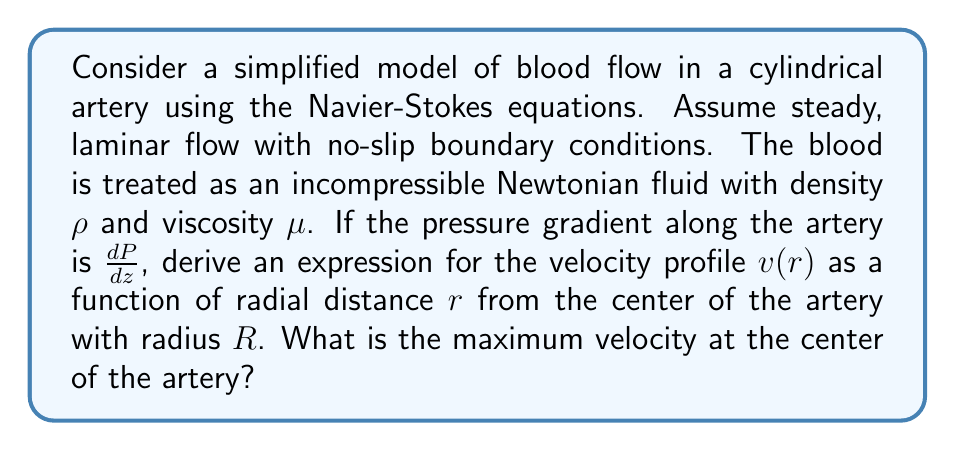Help me with this question. To solve this problem, we'll use the Navier-Stokes equations for incompressible, steady-state flow in cylindrical coordinates. Given the assumptions, we can simplify the equations as follows:

1) The flow is only in the z-direction, so $v_r = v_\theta = 0$ and $v_z = v(r)$.

2) The flow is steady-state, so $\frac{\partial v}{\partial t} = 0$.

3) The pressure gradient is constant along the z-axis: $\frac{dP}{dz} = constant$.

The simplified Navier-Stokes equation in the z-direction becomes:

$$\mu \left(\frac{1}{r}\frac{d}{dr}\left(r\frac{dv}{dr}\right)\right) = \frac{dP}{dz}$$

To solve this equation:

1) Integrate both sides with respect to $r$:

   $$\mu r\frac{dv}{dr} = \frac{1}{2}\frac{dP}{dz}r^2 + C_1$$

2) Divide by $r$ and integrate again:

   $$\mu v = \frac{1}{4}\frac{dP}{dz}r^2 + C_1\ln(r) + C_2$$

3) Apply boundary conditions:
   - At $r = R$, $v = 0$ (no-slip condition)
   - At $r = 0$, $\frac{dv}{dr} = 0$ (symmetry condition)

4) From the symmetry condition, we find that $C_1 = 0$.

5) From the no-slip condition:

   $$0 = \frac{1}{4}\frac{dP}{dz}R^2 + C_2$$
   $$C_2 = -\frac{1}{4}\frac{dP}{dz}R^2$$

6) Substituting back, we get the velocity profile:

   $$v(r) = \frac{1}{4\mu}\frac{dP}{dz}(r^2 - R^2)$$

7) The maximum velocity occurs at the center ($r = 0$):

   $$v_{max} = -\frac{R^2}{4\mu}\frac{dP}{dz}$$

Note that $\frac{dP}{dz}$ is negative as pressure decreases along the flow direction, making $v_{max}$ positive.
Answer: The velocity profile is:

$$v(r) = \frac{1}{4\mu}\frac{dP}{dz}(r^2 - R^2)$$

The maximum velocity at the center of the artery is:

$$v_{max} = -\frac{R^2}{4\mu}\frac{dP}{dz}$$ 